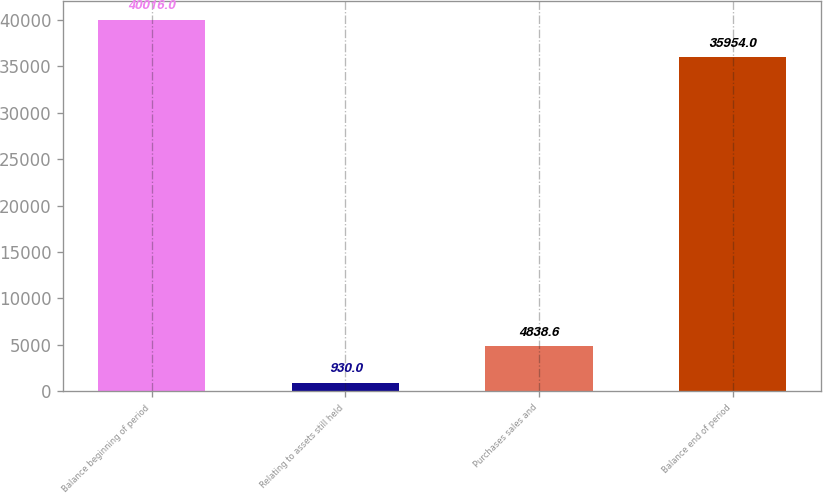Convert chart. <chart><loc_0><loc_0><loc_500><loc_500><bar_chart><fcel>Balance beginning of period<fcel>Relating to assets still held<fcel>Purchases sales and<fcel>Balance end of period<nl><fcel>40016<fcel>930<fcel>4838.6<fcel>35954<nl></chart> 